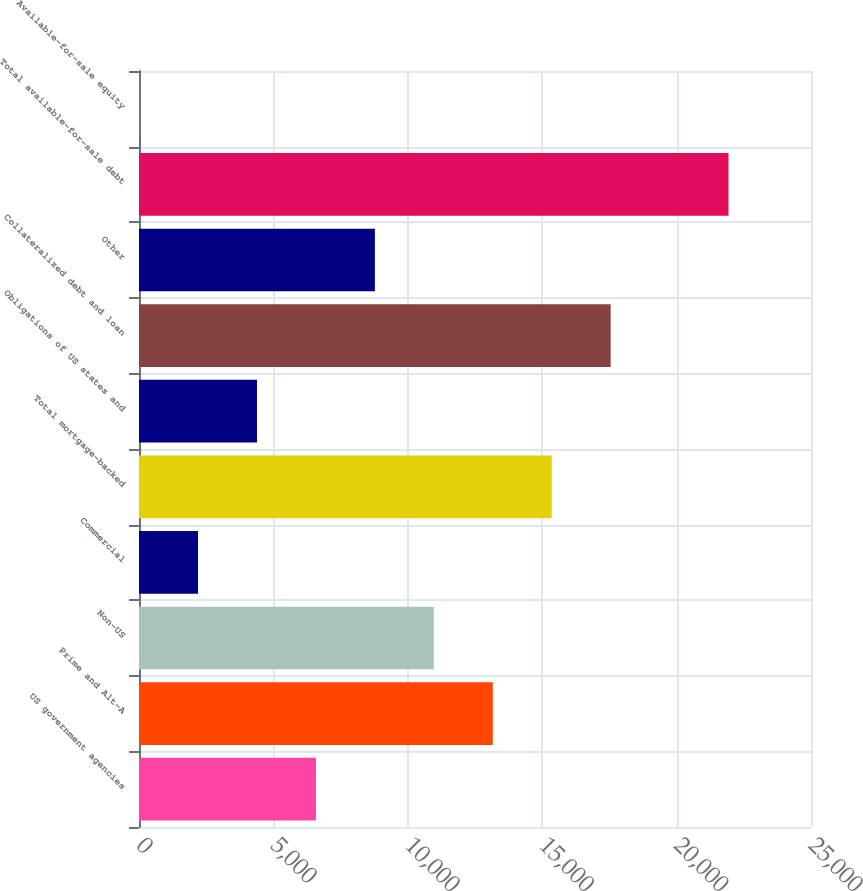Convert chart to OTSL. <chart><loc_0><loc_0><loc_500><loc_500><bar_chart><fcel>US government agencies<fcel>Prime and Alt-A<fcel>Non-US<fcel>Commercial<fcel>Total mortgage-backed<fcel>Obligations of US states and<fcel>Collateralized debt and loan<fcel>Other<fcel>Total available-for-sale debt<fcel>Available-for-sale equity<nl><fcel>6582.3<fcel>13161.6<fcel>10968.5<fcel>2196.1<fcel>15354.7<fcel>4389.2<fcel>17547.8<fcel>8775.4<fcel>21931<fcel>3<nl></chart> 